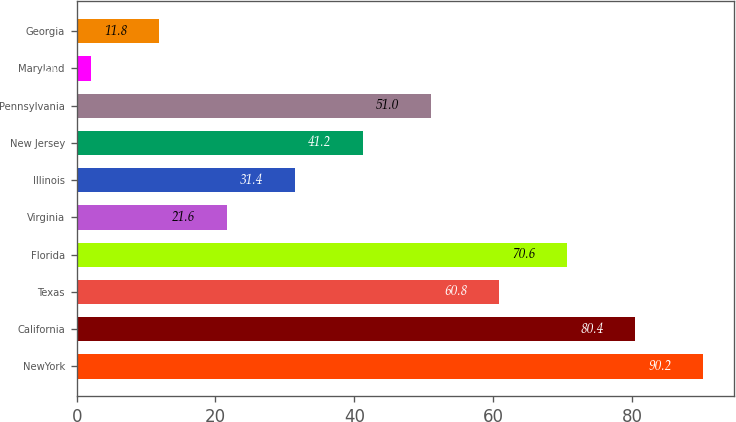<chart> <loc_0><loc_0><loc_500><loc_500><bar_chart><fcel>NewYork<fcel>California<fcel>Texas<fcel>Florida<fcel>Virginia<fcel>Illinois<fcel>New Jersey<fcel>Pennsylvania<fcel>Maryland<fcel>Georgia<nl><fcel>90.2<fcel>80.4<fcel>60.8<fcel>70.6<fcel>21.6<fcel>31.4<fcel>41.2<fcel>51<fcel>2<fcel>11.8<nl></chart> 